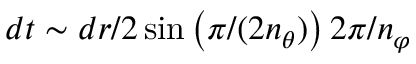Convert formula to latex. <formula><loc_0><loc_0><loc_500><loc_500>d t \sim d r / 2 \sin \left ( \pi / ( 2 n _ { \theta } ) \right ) 2 \pi / n _ { \varphi }</formula> 